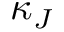Convert formula to latex. <formula><loc_0><loc_0><loc_500><loc_500>\kappa _ { J }</formula> 